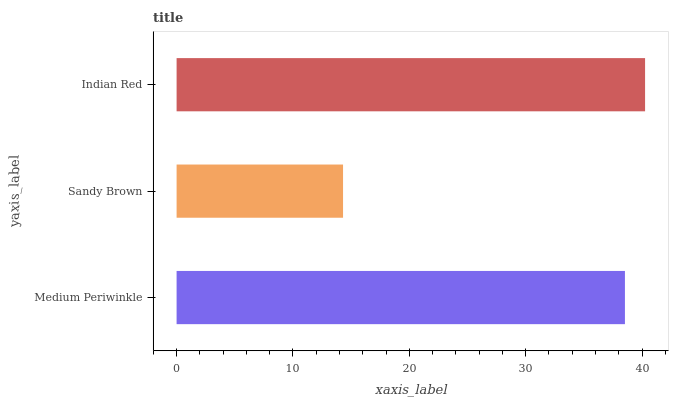Is Sandy Brown the minimum?
Answer yes or no. Yes. Is Indian Red the maximum?
Answer yes or no. Yes. Is Indian Red the minimum?
Answer yes or no. No. Is Sandy Brown the maximum?
Answer yes or no. No. Is Indian Red greater than Sandy Brown?
Answer yes or no. Yes. Is Sandy Brown less than Indian Red?
Answer yes or no. Yes. Is Sandy Brown greater than Indian Red?
Answer yes or no. No. Is Indian Red less than Sandy Brown?
Answer yes or no. No. Is Medium Periwinkle the high median?
Answer yes or no. Yes. Is Medium Periwinkle the low median?
Answer yes or no. Yes. Is Indian Red the high median?
Answer yes or no. No. Is Sandy Brown the low median?
Answer yes or no. No. 